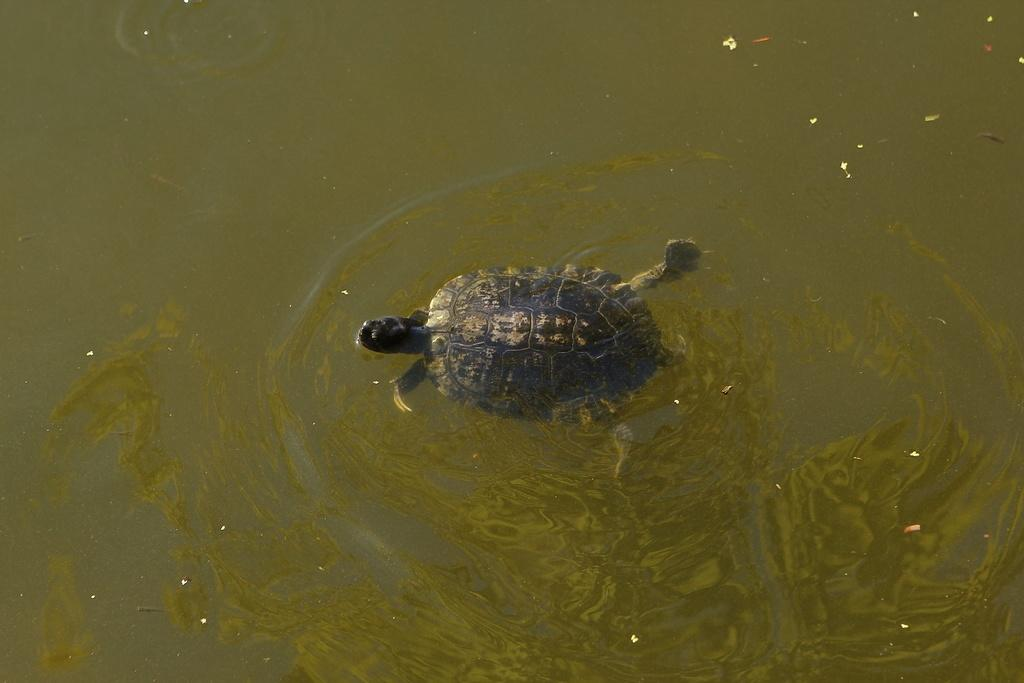What type of animal is in the image? There is a tortoise in the image. What is the tortoise doing in the image? The tortoise is swimming in the water. What type of magic is the tortoise performing in the image? There is no magic or any magical activity performed by the tortoise in the image; it is simply swimming in the water. Can you tell me where the tortoise is located in the image, on land or in the water? The tortoise is located in the water, not on land, as it is swimming in the water. 